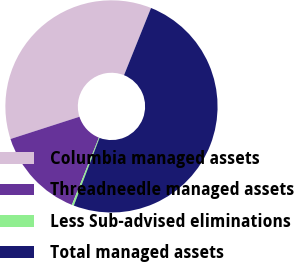Convert chart to OTSL. <chart><loc_0><loc_0><loc_500><loc_500><pie_chart><fcel>Columbia managed assets<fcel>Threadneedle managed assets<fcel>Less Sub-advised eliminations<fcel>Total managed assets<nl><fcel>36.05%<fcel>13.95%<fcel>0.31%<fcel>49.69%<nl></chart> 